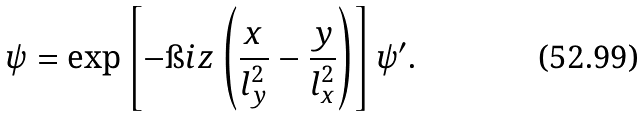<formula> <loc_0><loc_0><loc_500><loc_500>\psi = \exp \left [ - \i i z \left ( \frac { x } { l _ { y } ^ { 2 } } - \frac { y } { l _ { x } ^ { 2 } } \right ) \right ] \psi ^ { \prime } .</formula> 